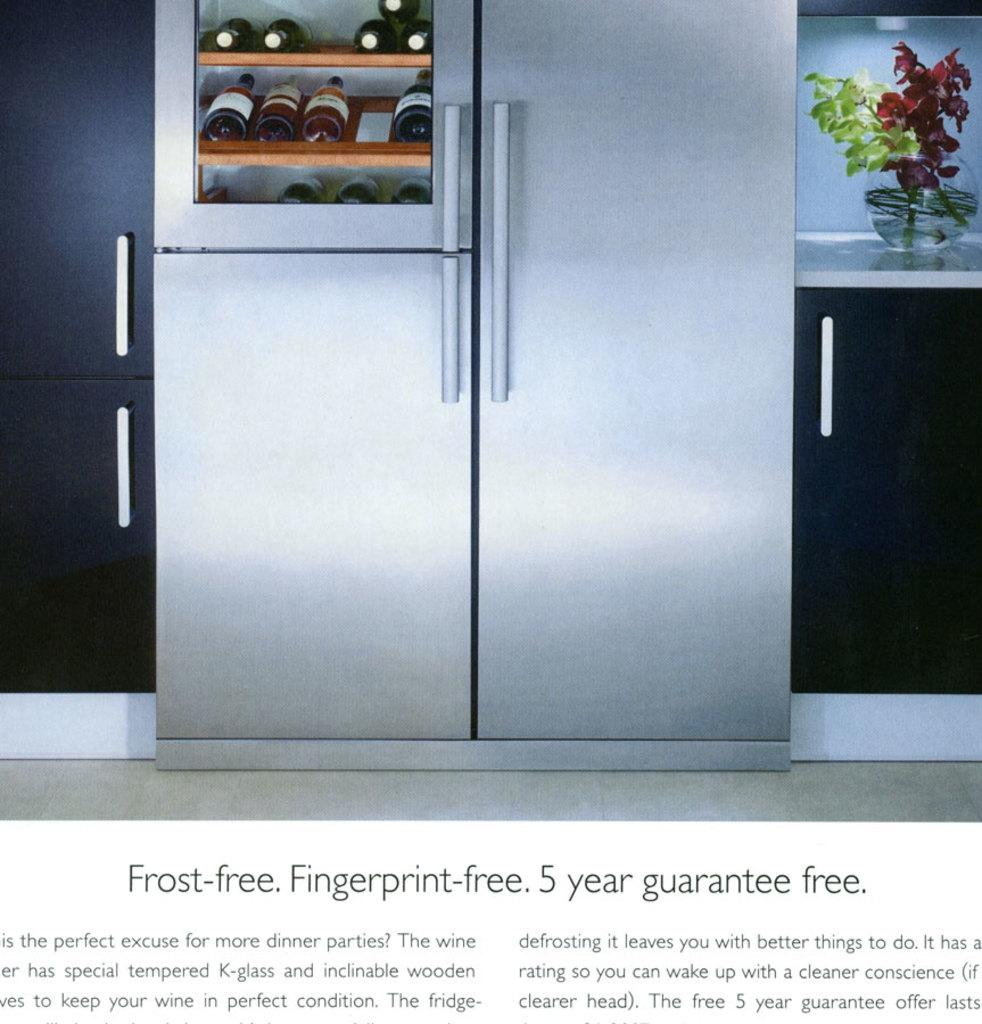<image>
Give a short and clear explanation of the subsequent image. Wine refrigeration advertisement with a 5 year guarantee. 